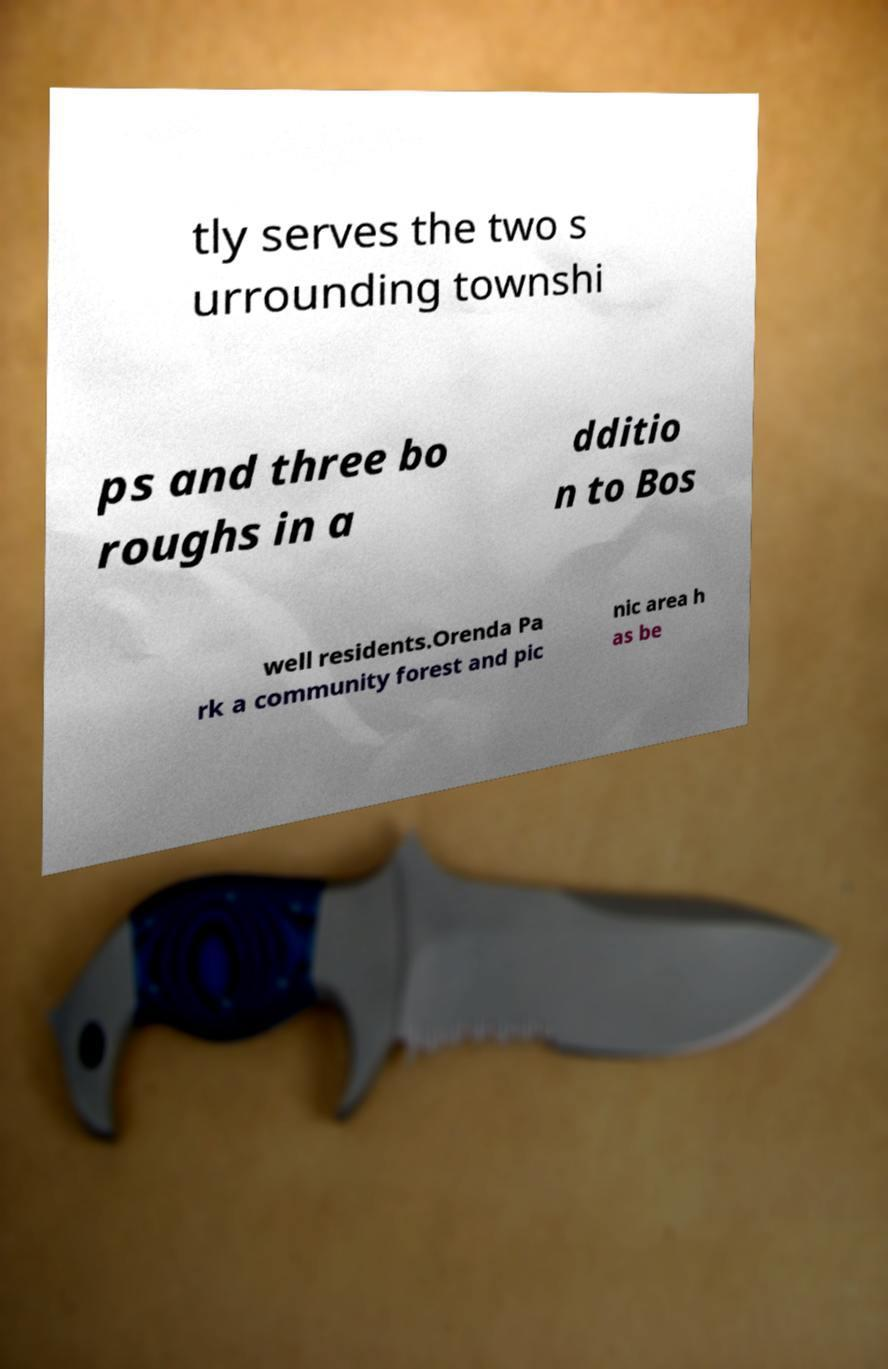For documentation purposes, I need the text within this image transcribed. Could you provide that? tly serves the two s urrounding townshi ps and three bo roughs in a dditio n to Bos well residents.Orenda Pa rk a community forest and pic nic area h as be 